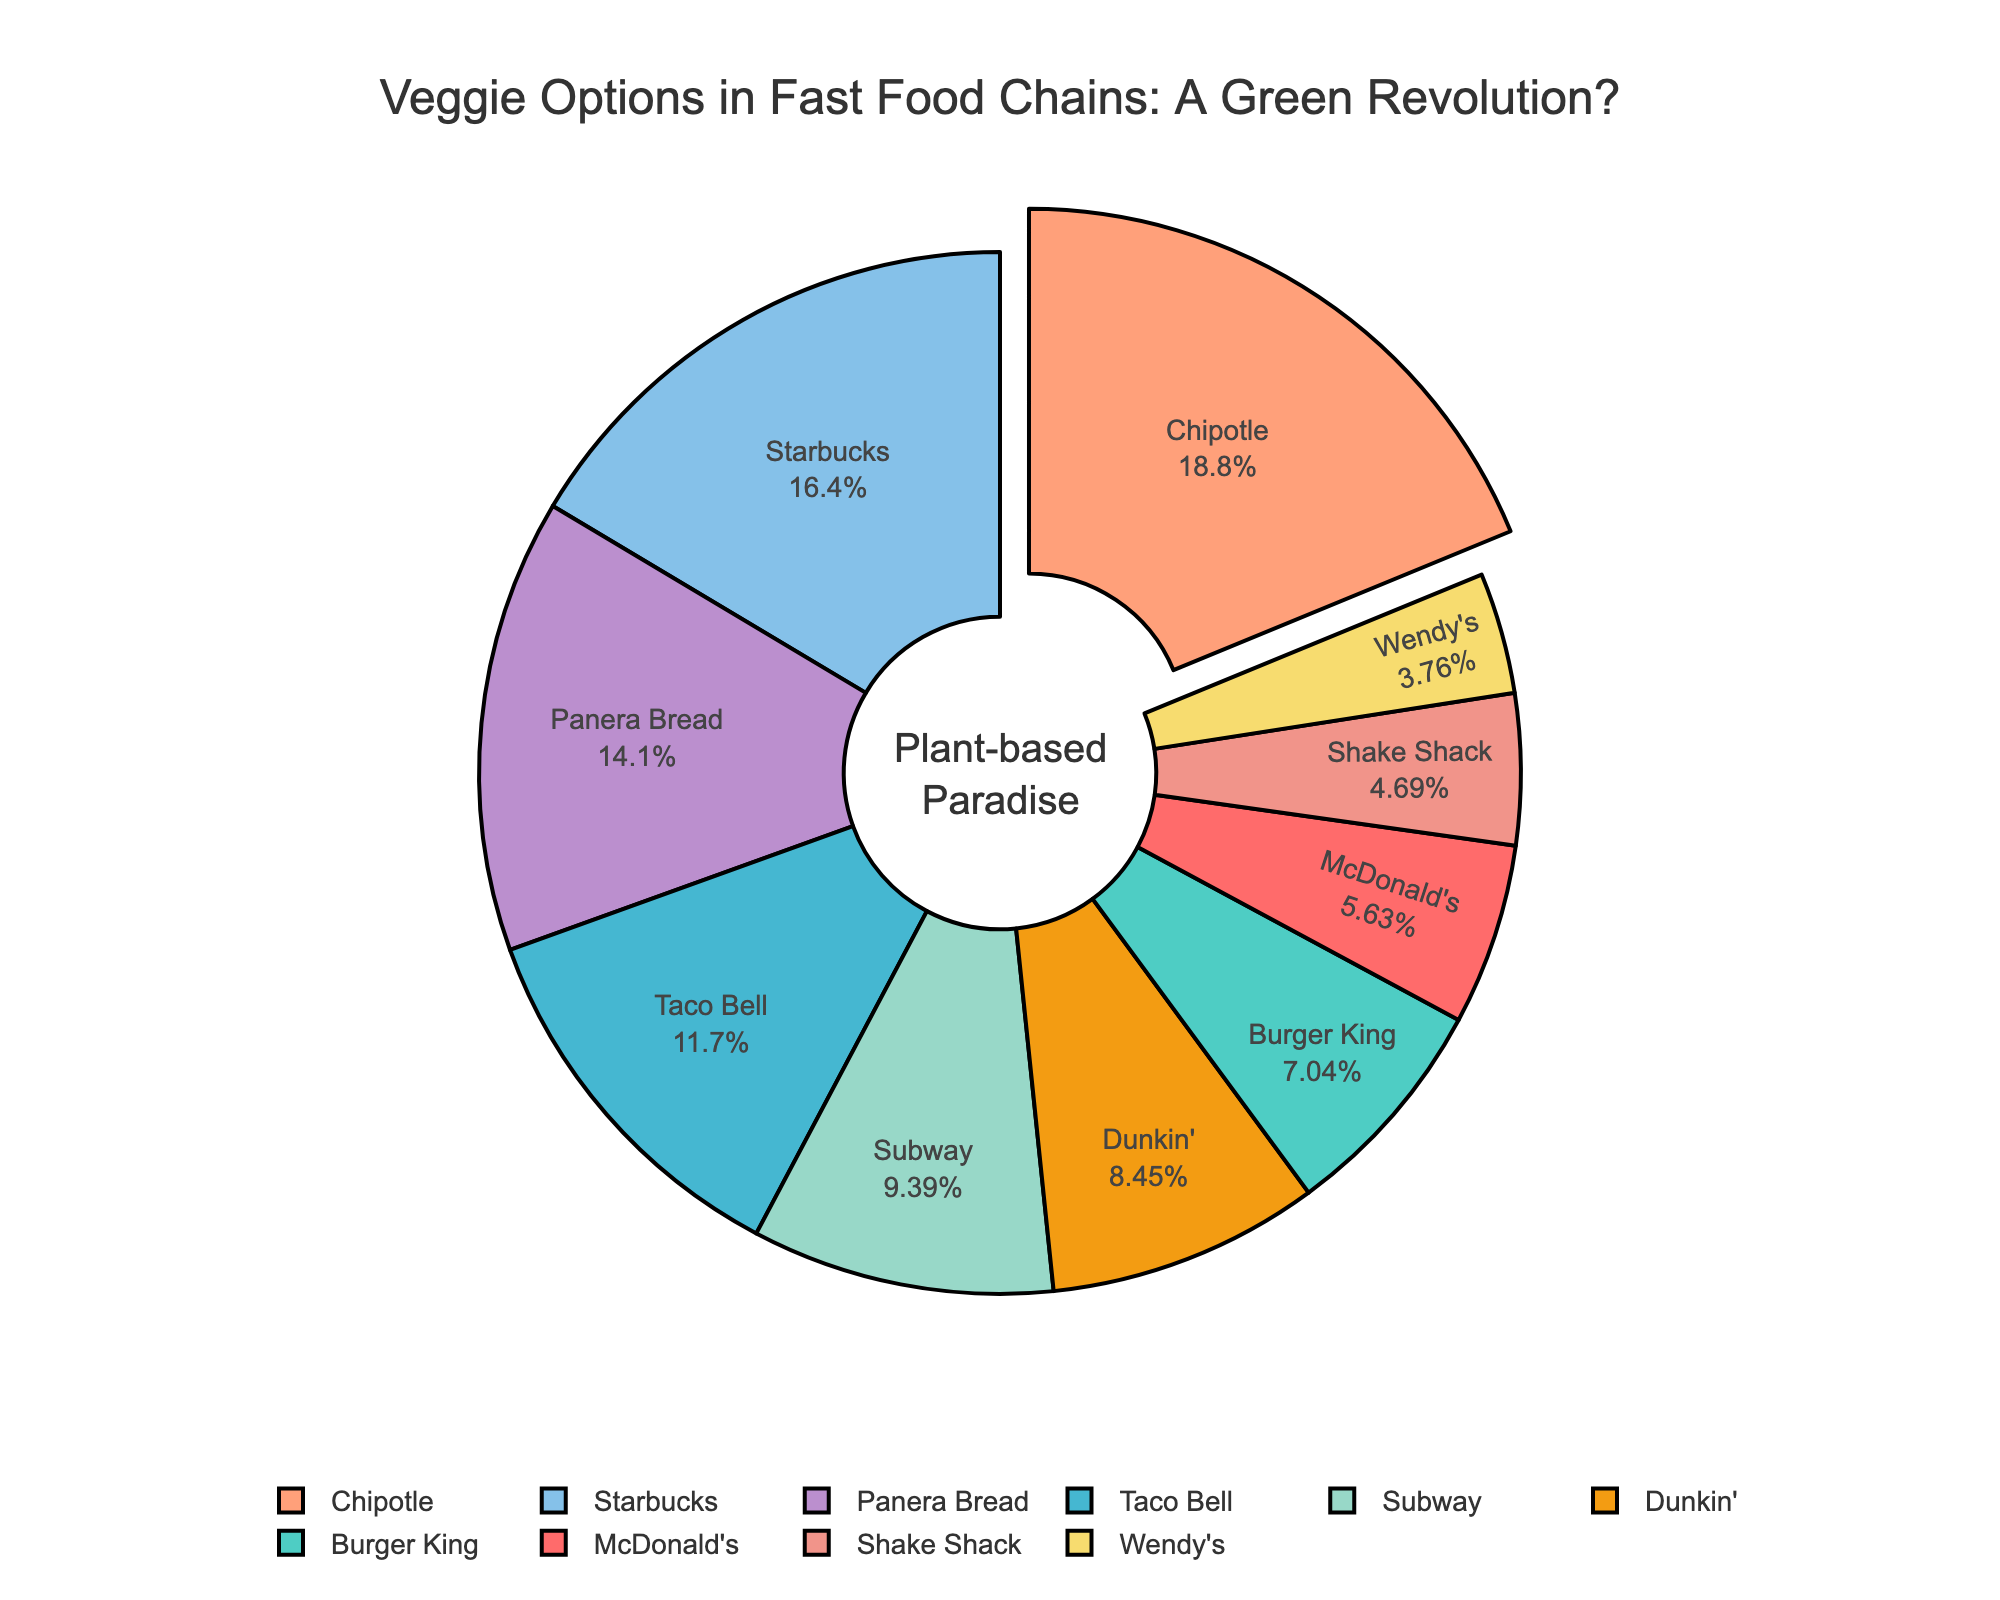Which fast-food chain offers the highest percentage of vegetarian options? The slice with the largest pull-out effect in the pie chart indicates the highest percentage. This belongs to Chipotle.
Answer: Chipotle Among McDonald's, Burger King, and Wendy's, which chain provides the fewest vegetarian options? By comparing the labeled percentages in the pie chart, McDonald's shows 12%, Burger King 15%, and Wendy's 8%. Wendy's has the lowest percentage.
Answer: Wendy's What is the cumulative percentage of vegetarian options offered by Panera Bread and Starbucks? Add Panera Bread's 30% and Starbucks' 35% based on the pie chart's labels to find the total. 30% + 35% equals 65%.
Answer: 65% Compare the percentage of vegetarian options between Taco Bell and Subway. Which one offers more, and by how much? Taco Bell's slice shows 25%, and Subway's slice shows 20%. The difference is 25% - 20% = 5%. Taco Bell offers 5% more.
Answer: Taco Bell by 5% Which fast-food chain offers almost twice the percentage of vegetarian options compared to McDonald's? McDonald's offers 12%. Starbucks provides 35%, which is close to three times 12%. Since 12% doubled is 24%, no chain offers exactly twice, but Taco Bell's 25% is close.
Answer: Taco Bell Summing up the percentages for McDonald's, Burger King, Wendy's, and Shake Shack, what do you get? Add the labeled values of McDonald's (12%), Burger King (15%), Wendy's (8%), and Shake Shack (10%). 12% + 15% + 8% + 10% equals 45%.
Answer: 45% How many chains offer a higher percentage of vegetarian options than Burger King? Burger King offers 15%. Chains with higher percentages are Taco Bell (25%), Chipotle (40%), Subway (20%), Panera Bread (30%), and Starbucks (35%). There are five chains.
Answer: 5 Which chain offers fewer vegetarian options, Dunkin' or Shake Shack? Comparing the labeled percentages shows Dunkin' at 18% and Shake Shack at 10%. Shake Shack offers fewer.
Answer: Shake Shack 